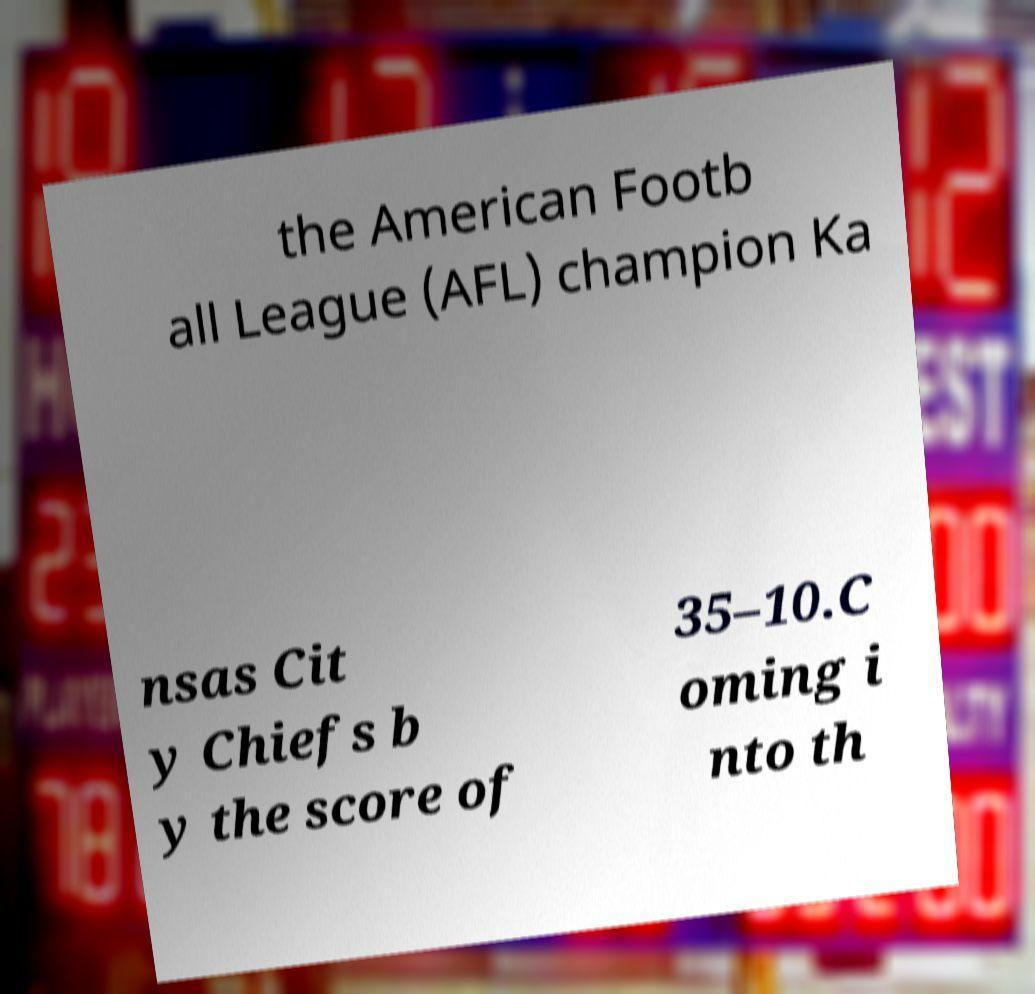What messages or text are displayed in this image? I need them in a readable, typed format. the American Footb all League (AFL) champion Ka nsas Cit y Chiefs b y the score of 35–10.C oming i nto th 